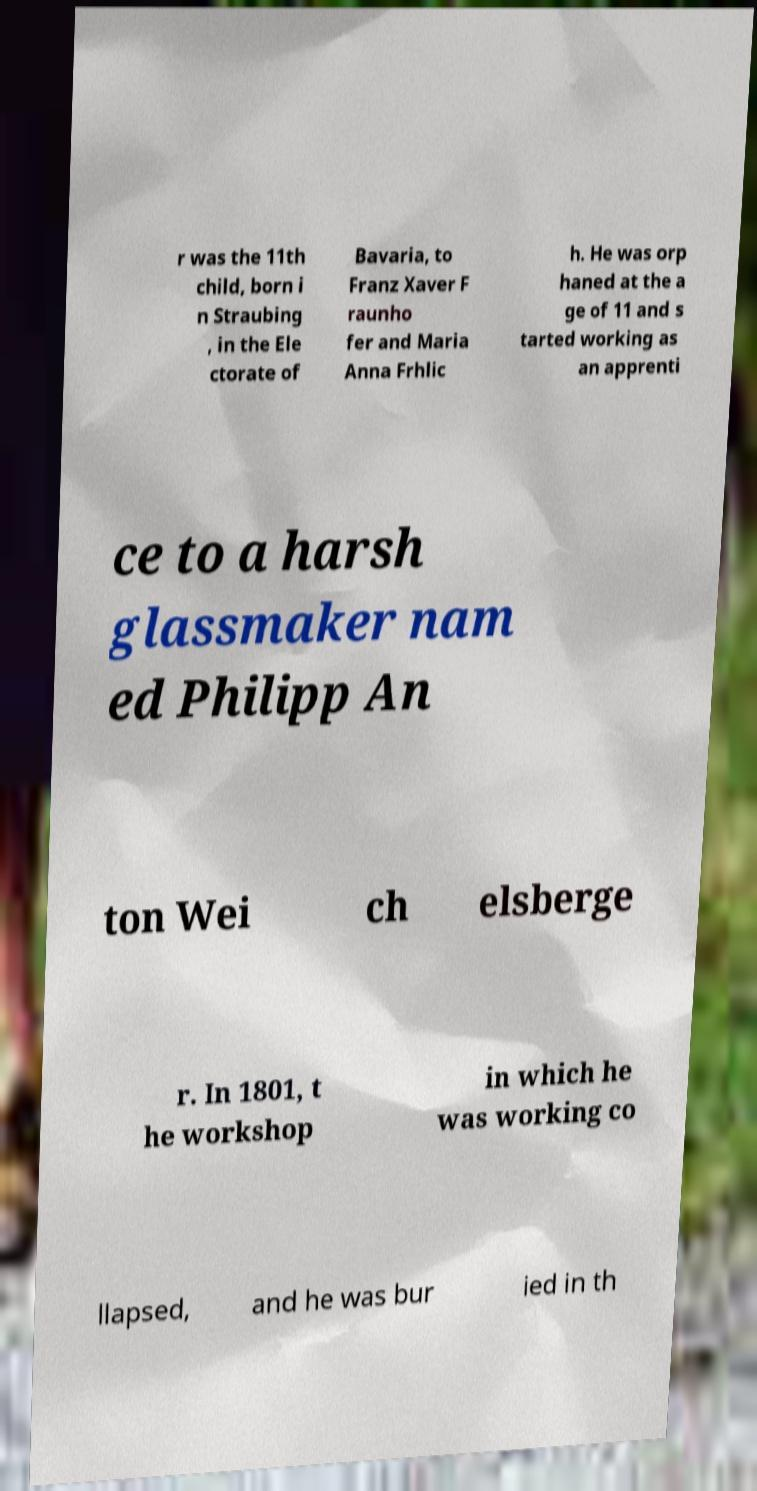For documentation purposes, I need the text within this image transcribed. Could you provide that? r was the 11th child, born i n Straubing , in the Ele ctorate of Bavaria, to Franz Xaver F raunho fer and Maria Anna Frhlic h. He was orp haned at the a ge of 11 and s tarted working as an apprenti ce to a harsh glassmaker nam ed Philipp An ton Wei ch elsberge r. In 1801, t he workshop in which he was working co llapsed, and he was bur ied in th 